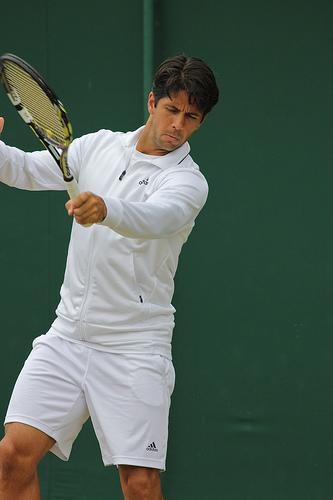Question: what is he wearing?
Choices:
A. Shorts.
B. Shirt.
C. Pants.
D. Cleats.
Answer with the letter. Answer: A Question: when was the pic taken?
Choices:
A. During the day.
B. At night.
C. At dusk.
D. At sunrise.
Answer with the letter. Answer: A Question: why is he looking down?
Choices:
A. Looking at the sand.
B. Looking at the flowers.
C. Looking at the sidewalk.
D. Looking at the ball.
Answer with the letter. Answer: D Question: who is he with?
Choices:
A. A woman.
B. No one.
C. A man.
D. A child.
Answer with the letter. Answer: B Question: what is he holding?
Choices:
A. A bat.
B. A golf club.
C. A soccer ball.
D. A racket.
Answer with the letter. Answer: D Question: what is the color of the short?
Choices:
A. Red.
B. White.
C. Blue.
D. Khaki.
Answer with the letter. Answer: B 